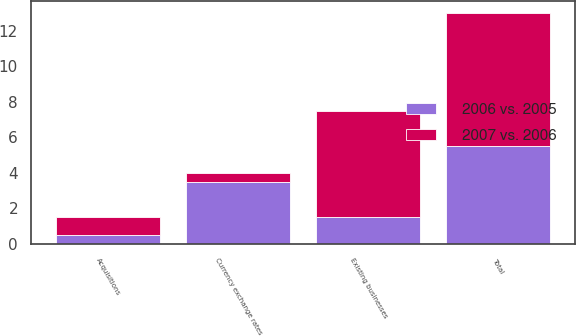<chart> <loc_0><loc_0><loc_500><loc_500><stacked_bar_chart><ecel><fcel>Existing businesses<fcel>Acquisitions<fcel>Currency exchange rates<fcel>Total<nl><fcel>2006 vs. 2005<fcel>1.5<fcel>0.5<fcel>3.5<fcel>5.5<nl><fcel>2007 vs. 2006<fcel>6<fcel>1<fcel>0.5<fcel>7.5<nl></chart> 